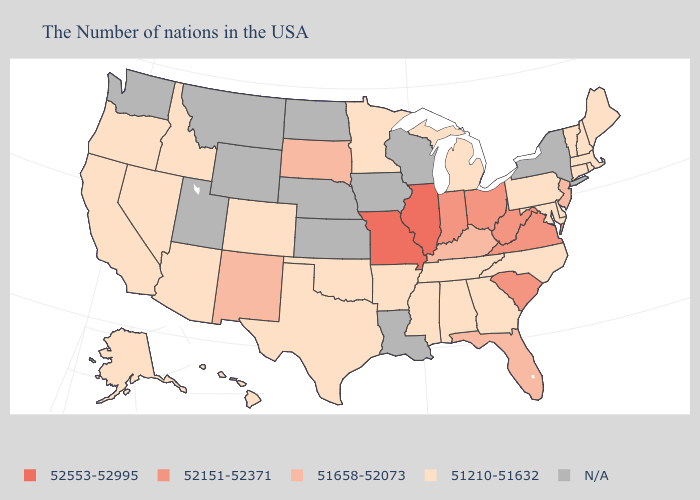Name the states that have a value in the range 52151-52371?
Short answer required. Virginia, South Carolina, West Virginia, Ohio, Indiana. Name the states that have a value in the range N/A?
Write a very short answer. New York, Wisconsin, Louisiana, Iowa, Kansas, Nebraska, North Dakota, Wyoming, Utah, Montana, Washington. What is the highest value in the South ?
Keep it brief. 52151-52371. What is the lowest value in the USA?
Be succinct. 51210-51632. How many symbols are there in the legend?
Be succinct. 5. What is the value of Pennsylvania?
Concise answer only. 51210-51632. Among the states that border Nebraska , does Colorado have the highest value?
Quick response, please. No. Does South Dakota have the highest value in the USA?
Give a very brief answer. No. Name the states that have a value in the range 51210-51632?
Short answer required. Maine, Massachusetts, Rhode Island, New Hampshire, Vermont, Connecticut, Delaware, Maryland, Pennsylvania, North Carolina, Georgia, Michigan, Alabama, Tennessee, Mississippi, Arkansas, Minnesota, Oklahoma, Texas, Colorado, Arizona, Idaho, Nevada, California, Oregon, Alaska, Hawaii. Which states have the lowest value in the South?
Write a very short answer. Delaware, Maryland, North Carolina, Georgia, Alabama, Tennessee, Mississippi, Arkansas, Oklahoma, Texas. What is the value of California?
Answer briefly. 51210-51632. Is the legend a continuous bar?
Be succinct. No. How many symbols are there in the legend?
Give a very brief answer. 5. Name the states that have a value in the range 51210-51632?
Be succinct. Maine, Massachusetts, Rhode Island, New Hampshire, Vermont, Connecticut, Delaware, Maryland, Pennsylvania, North Carolina, Georgia, Michigan, Alabama, Tennessee, Mississippi, Arkansas, Minnesota, Oklahoma, Texas, Colorado, Arizona, Idaho, Nevada, California, Oregon, Alaska, Hawaii. Among the states that border Arkansas , which have the highest value?
Write a very short answer. Missouri. 